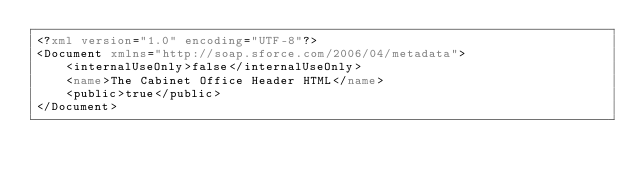Convert code to text. <code><loc_0><loc_0><loc_500><loc_500><_XML_><?xml version="1.0" encoding="UTF-8"?>
<Document xmlns="http://soap.sforce.com/2006/04/metadata">
    <internalUseOnly>false</internalUseOnly>
    <name>The Cabinet Office Header HTML</name>
    <public>true</public>
</Document>
</code> 